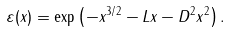Convert formula to latex. <formula><loc_0><loc_0><loc_500><loc_500>\varepsilon ( x ) = \exp \left ( - x ^ { 3 / 2 } - L x - D ^ { 2 } x ^ { 2 } \right ) .</formula> 